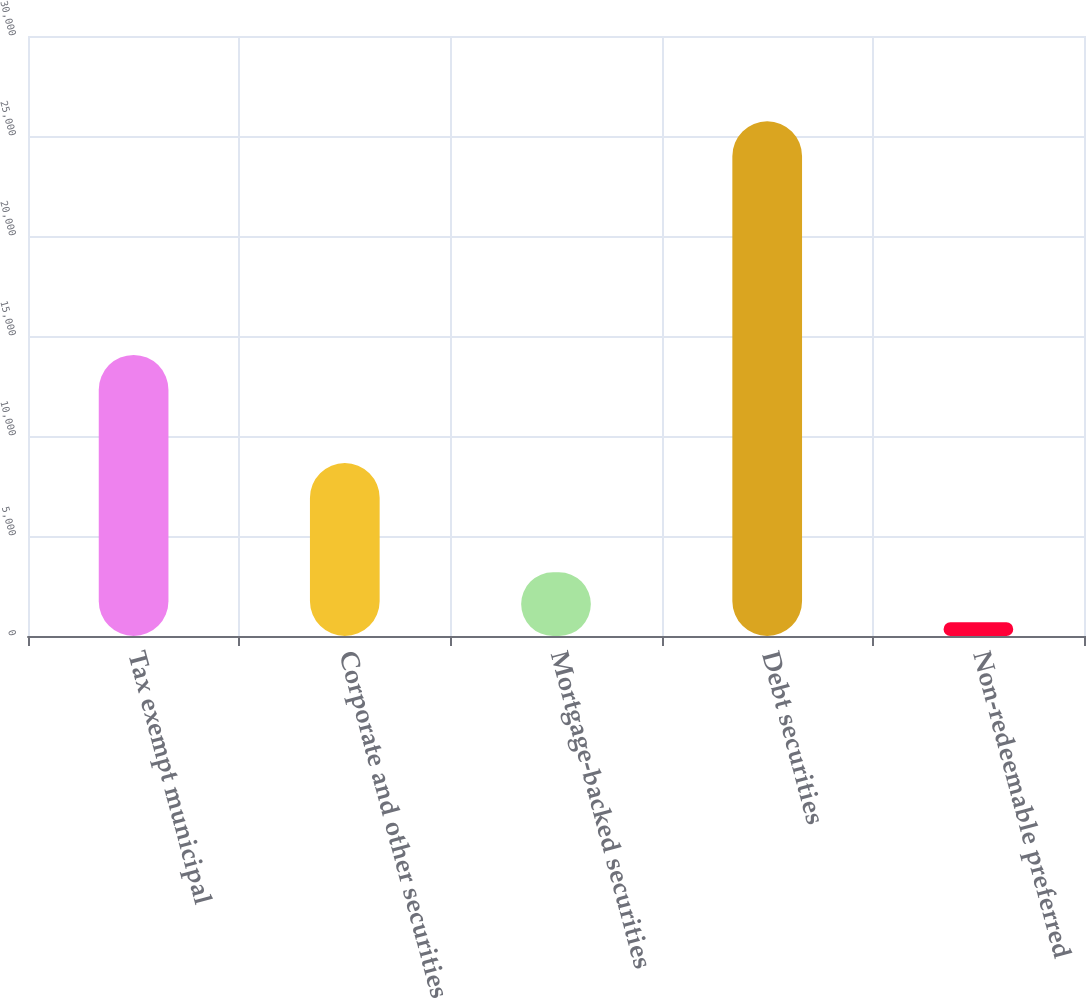Convert chart to OTSL. <chart><loc_0><loc_0><loc_500><loc_500><bar_chart><fcel>Tax exempt municipal<fcel>Corporate and other securities<fcel>Mortgage-backed securities<fcel>Debt securities<fcel>Non-redeemable preferred<nl><fcel>14056<fcel>8649<fcel>3187.9<fcel>25732<fcel>683<nl></chart> 